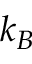<formula> <loc_0><loc_0><loc_500><loc_500>k _ { B }</formula> 